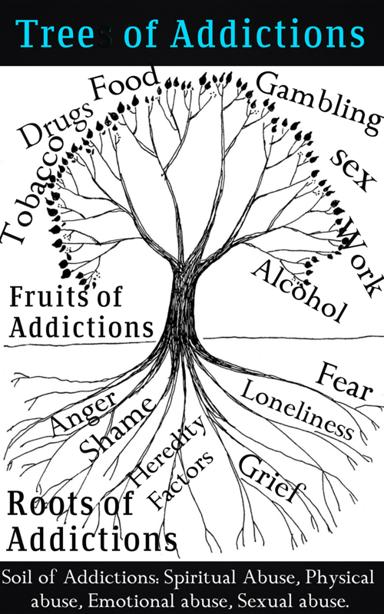What are the different parts of the Tree of Addictions mentioned in the image?
 In the image, the Tree of Addictions is divided into the following parts:
1. Addictions: Food, Gambling, Sex, and Alcohol.
2. Fruits of Addictions: Fear, Anger, Shame, Loneliness, and Grief.
3. Roots of Addictions: Heredity Factors.
4. Soil of Addictions: Spiritual Abuse, Physical Abuse, Emotional Abuse, and Sexual Abuse. What is the purpose of showing the Tree of Addictions in this way? The purpose of showing the Tree of Addictions in this way is to illustrate the complex relationship between different types of addictions, their consequences (fruits), underlying factors (roots), and the environment or experiences that may contribute to the development of addictions (soil). By visually representing this interconnected relationship, the image helps us understand how addictions can be rooted in various factors, and how they may manifest in different behaviors, emotions, and consequences. 